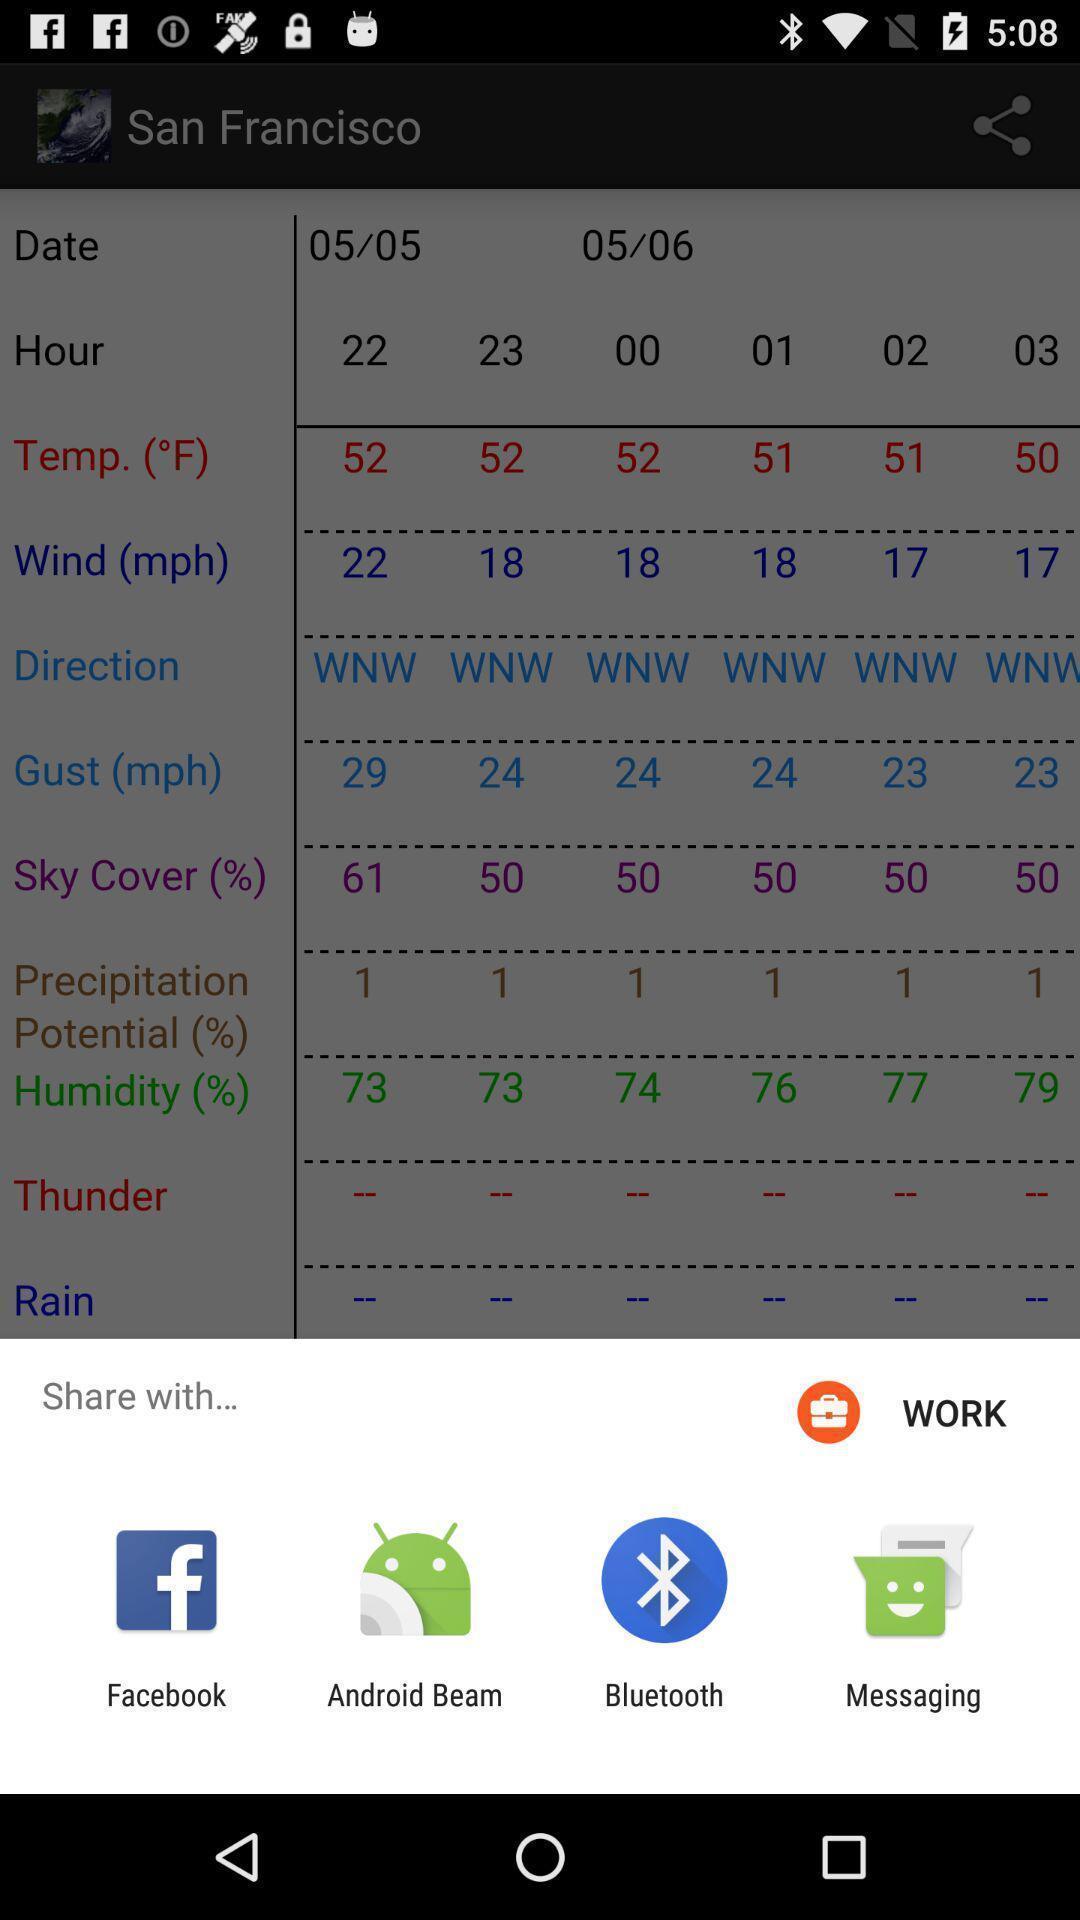Provide a description of this screenshot. Widget displaying multiple data sharing apps. 